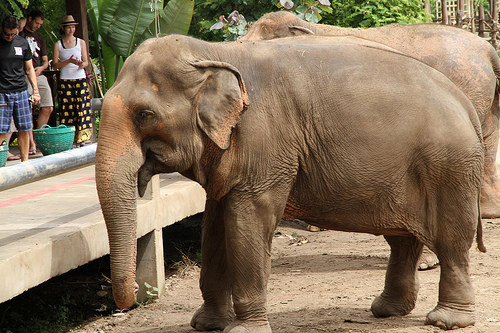What animal is the floor in front of? The floor is in front of an elephant. 